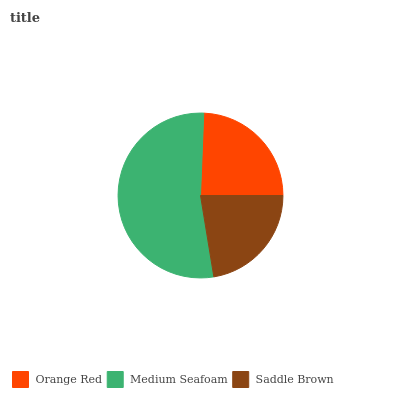Is Saddle Brown the minimum?
Answer yes or no. Yes. Is Medium Seafoam the maximum?
Answer yes or no. Yes. Is Medium Seafoam the minimum?
Answer yes or no. No. Is Saddle Brown the maximum?
Answer yes or no. No. Is Medium Seafoam greater than Saddle Brown?
Answer yes or no. Yes. Is Saddle Brown less than Medium Seafoam?
Answer yes or no. Yes. Is Saddle Brown greater than Medium Seafoam?
Answer yes or no. No. Is Medium Seafoam less than Saddle Brown?
Answer yes or no. No. Is Orange Red the high median?
Answer yes or no. Yes. Is Orange Red the low median?
Answer yes or no. Yes. Is Saddle Brown the high median?
Answer yes or no. No. Is Medium Seafoam the low median?
Answer yes or no. No. 